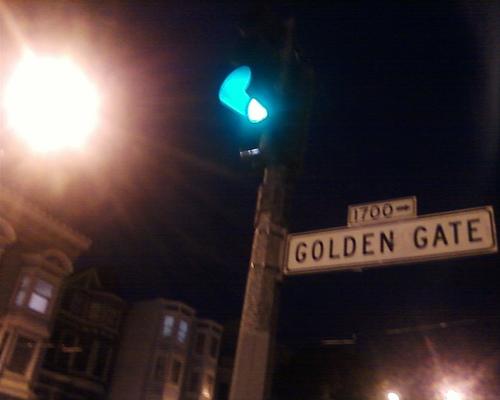Should cars at this light stop or go?
Be succinct. Go. What black of Golden Gate street is this picture of?
Concise answer only. 1700. What color is the stoplight?
Short answer required. Green. Is it night or day?
Concise answer only. Night. How many signs are visible?
Answer briefly. 1. What color is the traffic light on?
Short answer required. Green. What street are they on?
Answer briefly. Golden gate. 